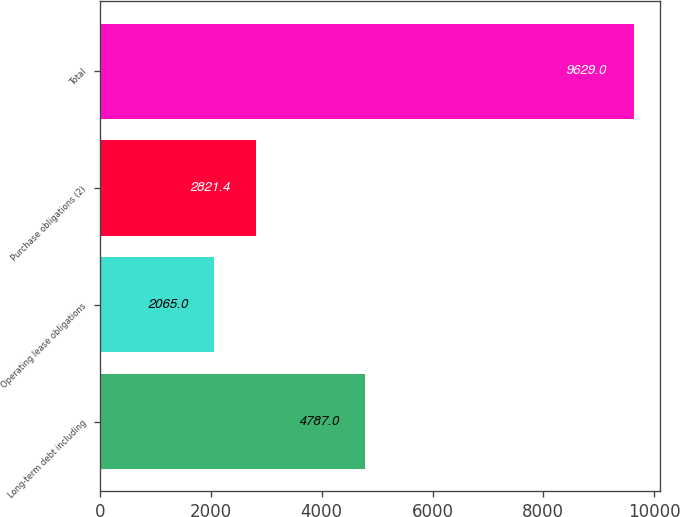<chart> <loc_0><loc_0><loc_500><loc_500><bar_chart><fcel>Long-term debt including<fcel>Operating lease obligations<fcel>Purchase obligations (2)<fcel>Total<nl><fcel>4787<fcel>2065<fcel>2821.4<fcel>9629<nl></chart> 